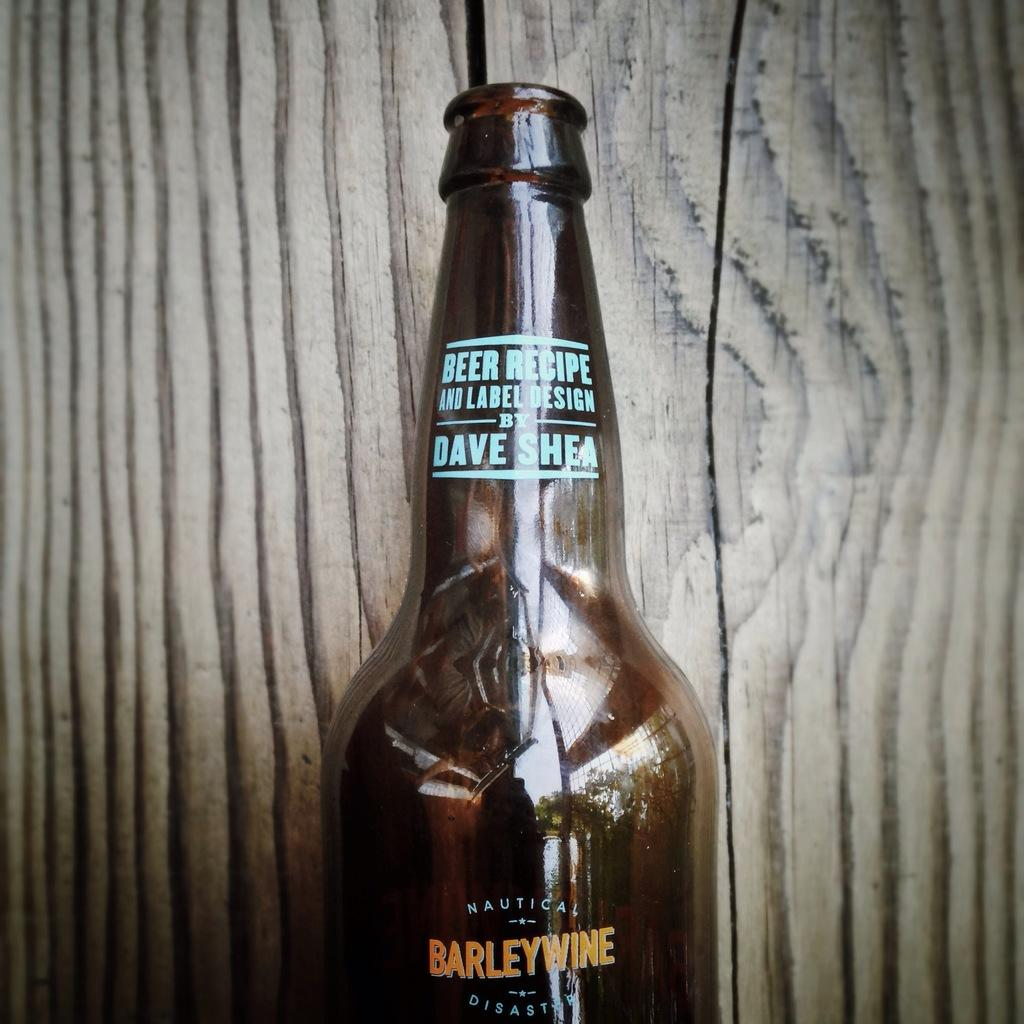Provide a one-sentence caption for the provided image. Half a barelywine beer bottle displayed against a wood background. 